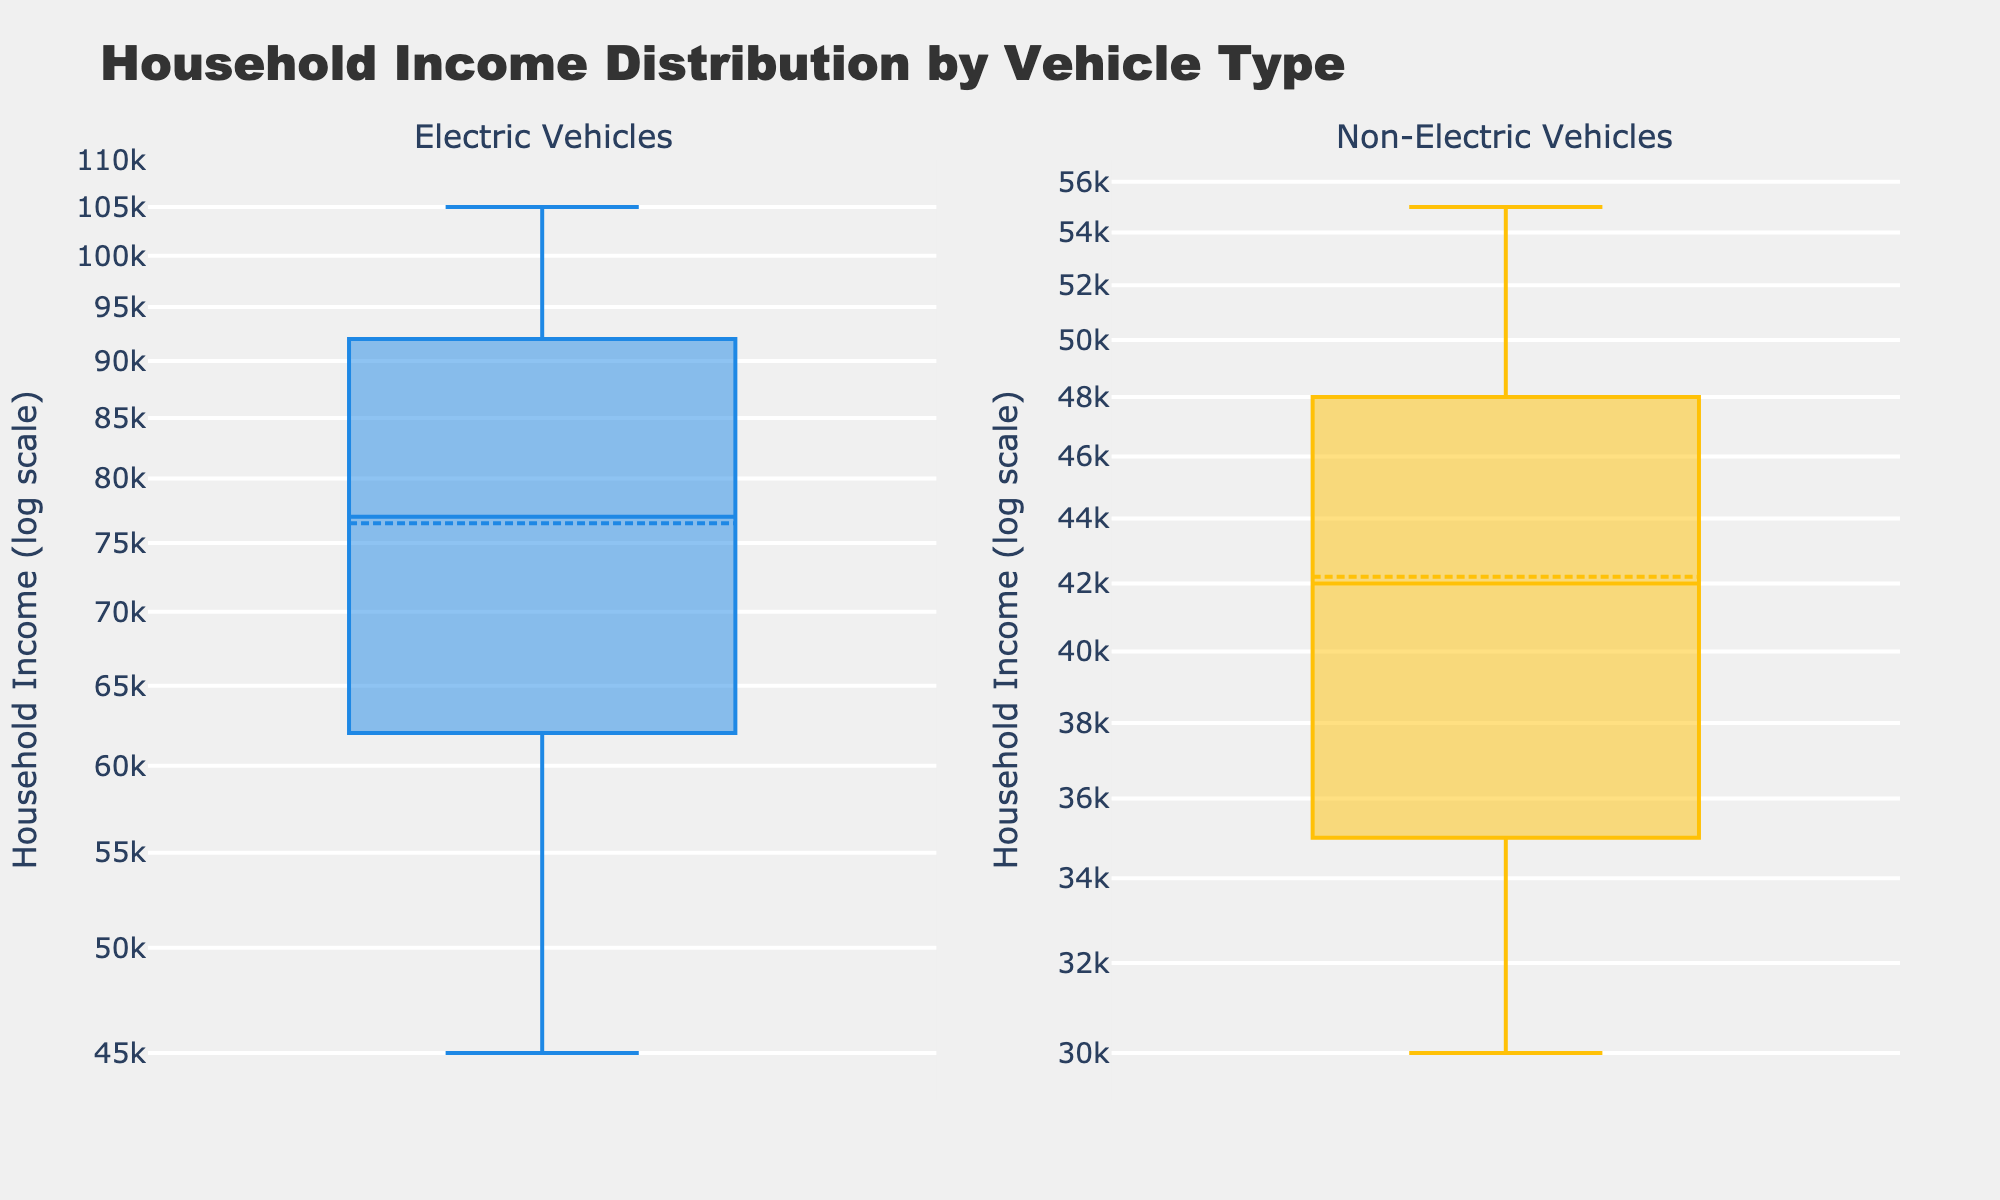What is the title of the figure? The title of the figure is displayed at the top and provides a summary of what the figure represents. In this case, it reads "Household Income Distribution by Vehicle Type".
Answer: Household Income Distribution by Vehicle Type What are the two types of vehicles compared in the figure? The figure includes two subplots, each representing a different type of vehicle. The left subplot is for "Electric Vehicles" and the right subplot is for "Non-Electric Vehicles".
Answer: Electric Vehicles, Non-Electric Vehicles Which subplot uses blue markers? The boxplot for "Electric Vehicles" uses markers that are colored blue. This can be observed by looking at the color of the box and whiskers in the left subplot.
Answer: Electric Vehicles Which subplot has the higher median household income? By examining the central line in the boxes of both subplots, which represents the median income, the subplot for "Electric Vehicles" has a significantly higher median than the subplot for "Non-Electric Vehicles".
Answer: Electric Vehicles How are household incomes represented on the y-axis? The y-axis of both subplots is labeled "Household Income (log scale)", indicating that the household incomes are plotted on a logarithmic scale.
Answer: Log scale Why is the y-axis plotted on a log scale? The log scale is used to better handle the wide range of household income values, compressing the higher incomes to allow for a clearer visualization of the distribution. This scale makes it easier to compare the income distributions and highlights differences more effectively.
Answer: To handle wide range of incomes Which vehicle type has higher variability in household incomes? Variability can be assessed by looking at the range and spread of the incomes in each boxplot. "Electric Vehicles" show a longer whisker and wider interquartile range, indicating higher variability in household incomes.
Answer: Electric Vehicles What can you say about the average income of households with non-electric vehicles? The figure shows a boxplot for "Non-Electric Vehicles" with a box mean marker. The average income is indicated by this marker, and it is lower compared to the households with "Electric Vehicles".
Answer: Lower than Electric Vehicles What does the top whisker in each boxplot represent? In a boxplot, the whiskers represent the range of the data within 1.5 times the interquartile range from the quartiles. The top whisker shows the highest income within this range for each vehicle type.
Answer: Highest income within 1.5 times the interquartile range By looking at both subplots, which type of vehicle is owned by wealthier households? Wealthier households are identified by their higher incomes. "Electric Vehicles" are predominantly owned by households with higher incomes, as indicated by their higher median and upper-income ranges.
Answer: Electric Vehicles 